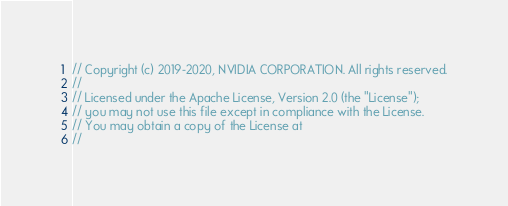<code> <loc_0><loc_0><loc_500><loc_500><_C++_>// Copyright (c) 2019-2020, NVIDIA CORPORATION. All rights reserved.
//
// Licensed under the Apache License, Version 2.0 (the "License");
// you may not use this file except in compliance with the License.
// You may obtain a copy of the License at
//</code> 